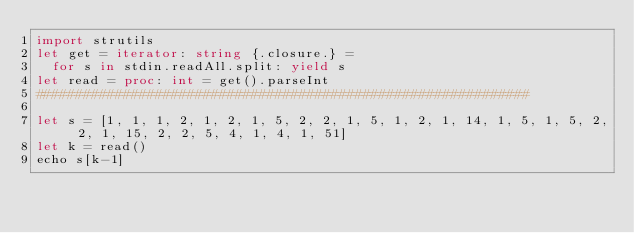<code> <loc_0><loc_0><loc_500><loc_500><_Nim_>import strutils
let get = iterator: string {.closure.} =
  for s in stdin.readAll.split: yield s
let read = proc: int = get().parseInt
##############################################################

let s = [1, 1, 1, 2, 1, 2, 1, 5, 2, 2, 1, 5, 1, 2, 1, 14, 1, 5, 1, 5, 2, 2, 1, 15, 2, 2, 5, 4, 1, 4, 1, 51]
let k = read()
echo s[k-1]</code> 